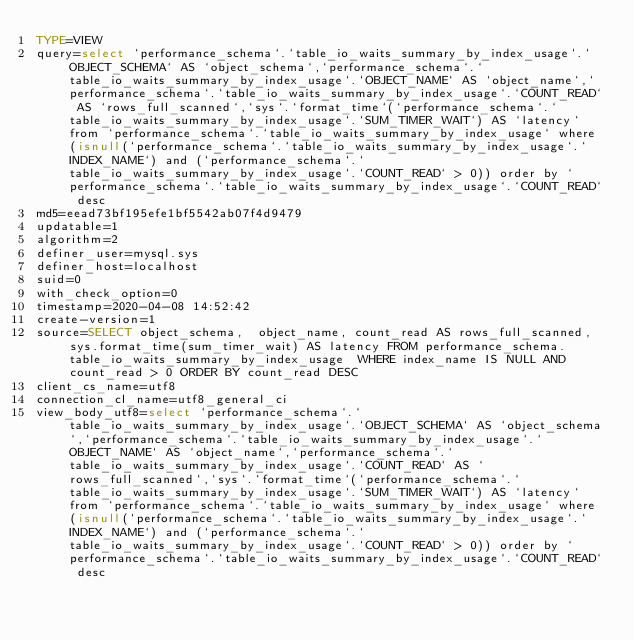<code> <loc_0><loc_0><loc_500><loc_500><_VisualBasic_>TYPE=VIEW
query=select `performance_schema`.`table_io_waits_summary_by_index_usage`.`OBJECT_SCHEMA` AS `object_schema`,`performance_schema`.`table_io_waits_summary_by_index_usage`.`OBJECT_NAME` AS `object_name`,`performance_schema`.`table_io_waits_summary_by_index_usage`.`COUNT_READ` AS `rows_full_scanned`,`sys`.`format_time`(`performance_schema`.`table_io_waits_summary_by_index_usage`.`SUM_TIMER_WAIT`) AS `latency` from `performance_schema`.`table_io_waits_summary_by_index_usage` where (isnull(`performance_schema`.`table_io_waits_summary_by_index_usage`.`INDEX_NAME`) and (`performance_schema`.`table_io_waits_summary_by_index_usage`.`COUNT_READ` > 0)) order by `performance_schema`.`table_io_waits_summary_by_index_usage`.`COUNT_READ` desc
md5=eead73bf195efe1bf5542ab07f4d9479
updatable=1
algorithm=2
definer_user=mysql.sys
definer_host=localhost
suid=0
with_check_option=0
timestamp=2020-04-08 14:52:42
create-version=1
source=SELECT object_schema,  object_name, count_read AS rows_full_scanned, sys.format_time(sum_timer_wait) AS latency FROM performance_schema.table_io_waits_summary_by_index_usage  WHERE index_name IS NULL AND count_read > 0 ORDER BY count_read DESC
client_cs_name=utf8
connection_cl_name=utf8_general_ci
view_body_utf8=select `performance_schema`.`table_io_waits_summary_by_index_usage`.`OBJECT_SCHEMA` AS `object_schema`,`performance_schema`.`table_io_waits_summary_by_index_usage`.`OBJECT_NAME` AS `object_name`,`performance_schema`.`table_io_waits_summary_by_index_usage`.`COUNT_READ` AS `rows_full_scanned`,`sys`.`format_time`(`performance_schema`.`table_io_waits_summary_by_index_usage`.`SUM_TIMER_WAIT`) AS `latency` from `performance_schema`.`table_io_waits_summary_by_index_usage` where (isnull(`performance_schema`.`table_io_waits_summary_by_index_usage`.`INDEX_NAME`) and (`performance_schema`.`table_io_waits_summary_by_index_usage`.`COUNT_READ` > 0)) order by `performance_schema`.`table_io_waits_summary_by_index_usage`.`COUNT_READ` desc
</code> 